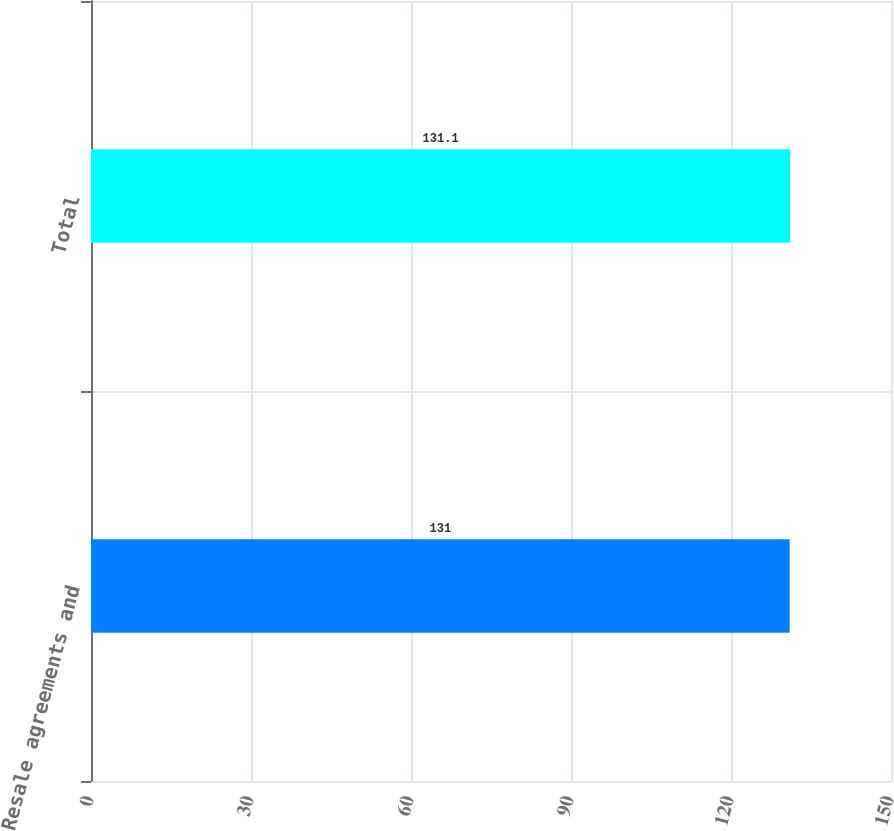Convert chart to OTSL. <chart><loc_0><loc_0><loc_500><loc_500><bar_chart><fcel>Resale agreements and<fcel>Total<nl><fcel>131<fcel>131.1<nl></chart> 